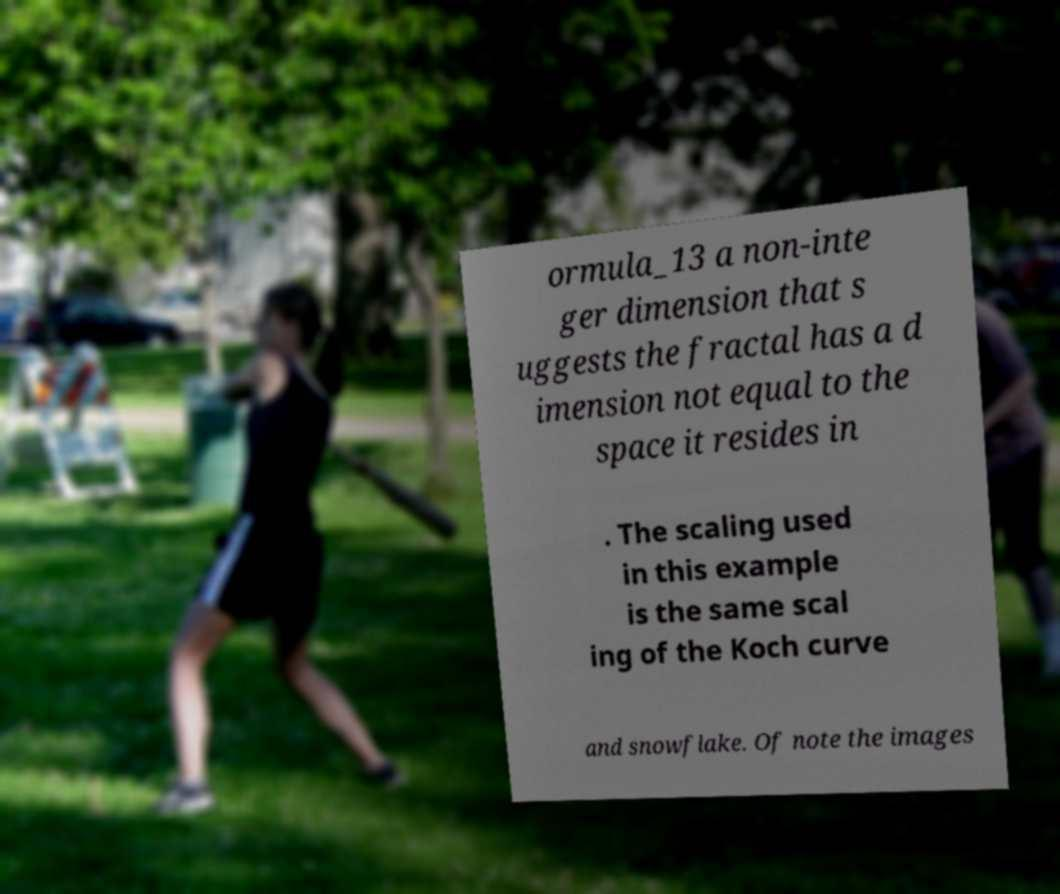Could you extract and type out the text from this image? ormula_13 a non-inte ger dimension that s uggests the fractal has a d imension not equal to the space it resides in . The scaling used in this example is the same scal ing of the Koch curve and snowflake. Of note the images 